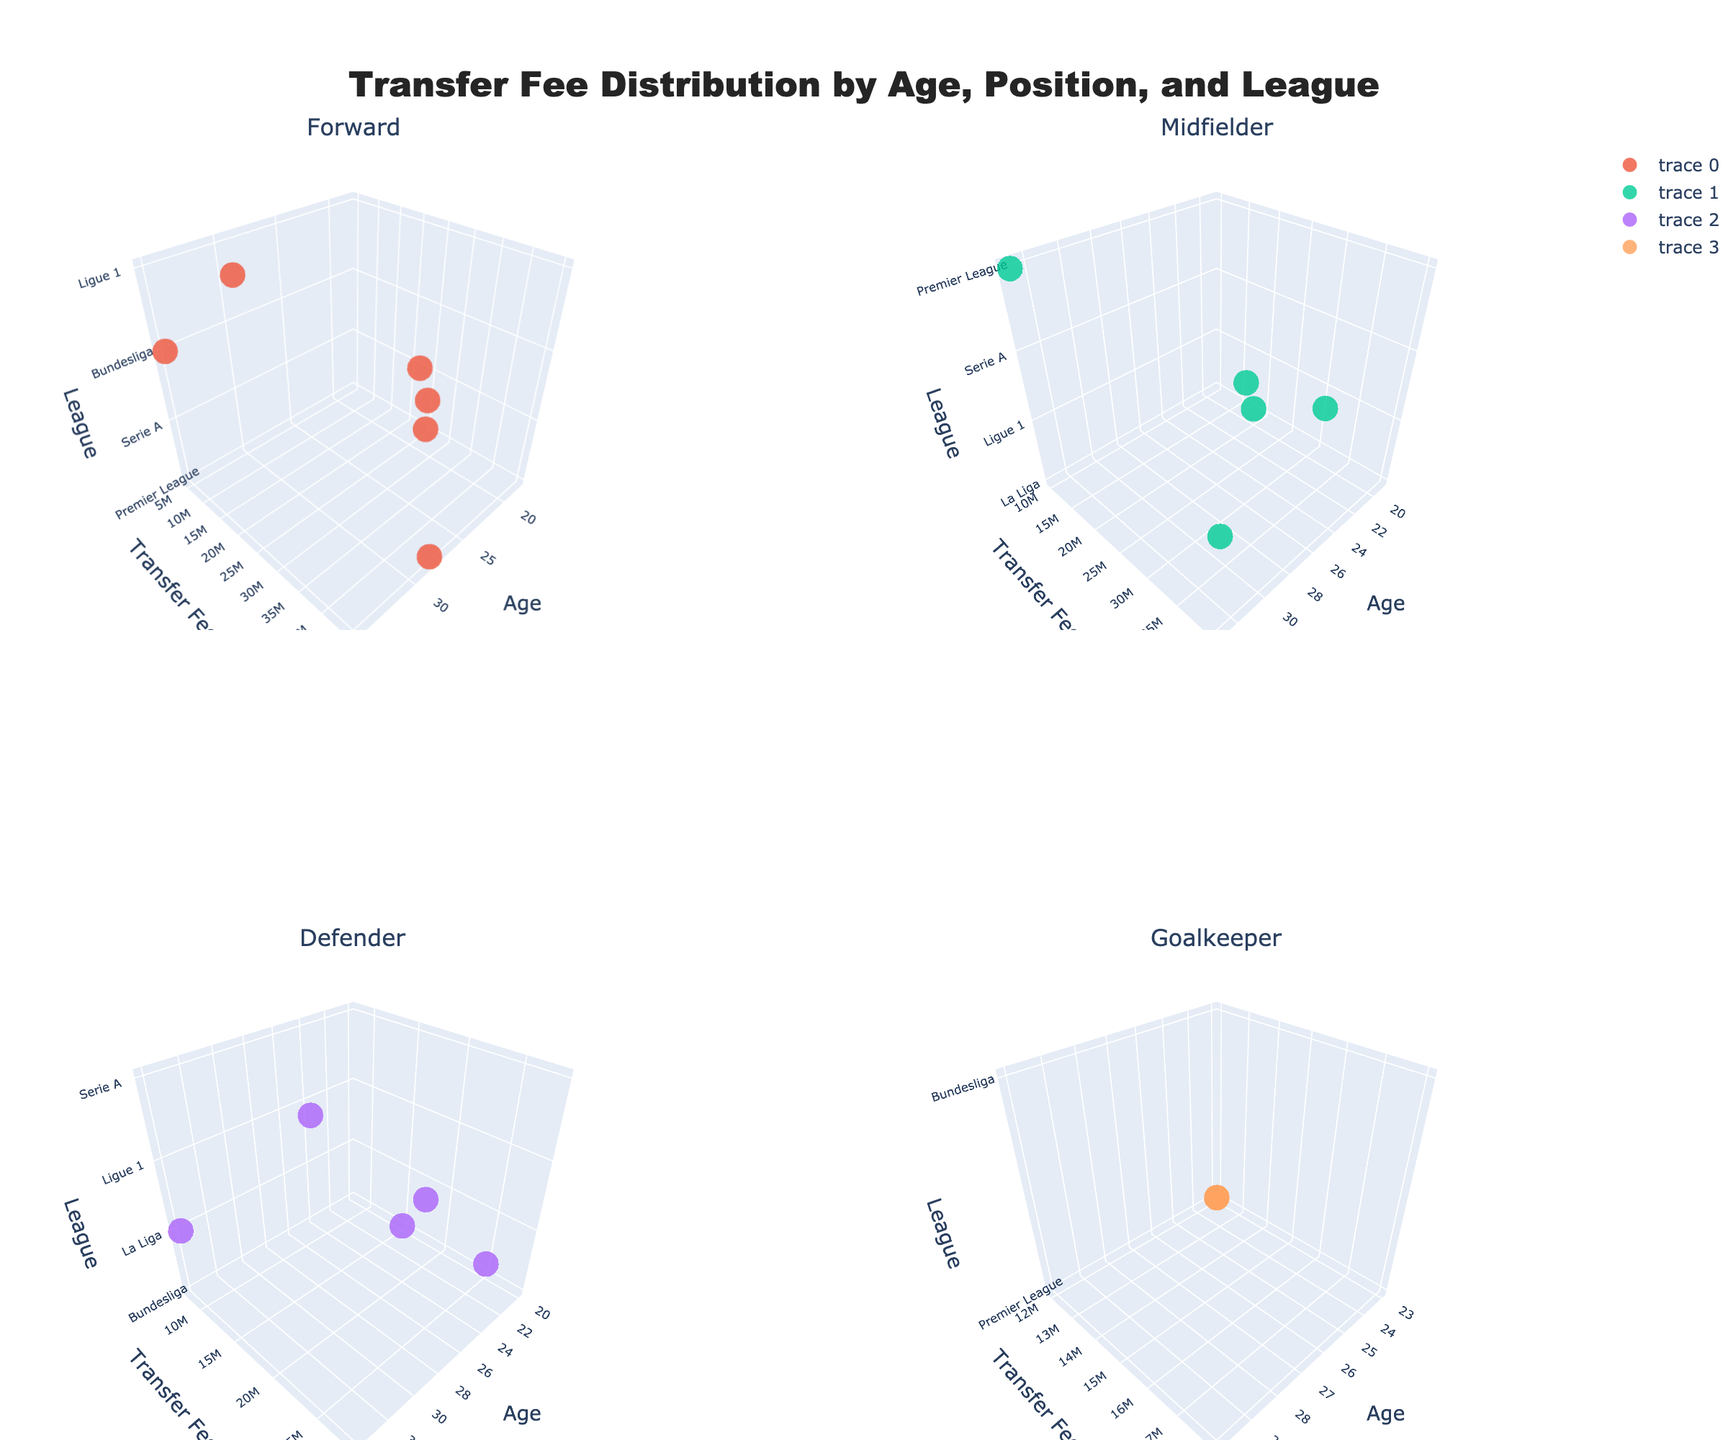what is the title of the figure? The title of the figure is located at the top center of the plot and it describes the overall content of the figure.
Answer: "Transfer Fee Distribution by Age, Position, and League" How many subplots are there in the figure? By looking at the layout of the figure, there are four distinct subplots indicated by separate titles and axis labels.
Answer: 4 Which position has the highest number of data points? By visually comparing the number of markers in each subplot, distinguish which subplot has the most markers. The Forward subplot appears to have the most markers.
Answer: Forward What are the axes labels for each subplot? Each subplot should have three axes labeled: Age on the x-axis, Transfer Fee (€) on the y-axis, and League on the z-axis.
Answer: Age, Transfer Fee (€), League Which age group in the Forward position has the highest transfer fee? In the Forward subplot, find the marker representing the highest position on the y-axis, and check the corresponding age on the x-axis. The highest Transfer Fee for the Forward position is at age 28.
Answer: 28 Are transfer fees generally higher for older Midfielders or younger ones? Observe the distribution of transfer fees along the y-axis for the Midfielders subplot. Compare the positions of markers for older age groups versus younger age groups. Overall, higher transfer fees are associated with Midfielders aged around 26-29.
Answer: Older Midfielders What is the trend in transfer fees for Defenders as they age? Look at the subplot for Defenders and observe how the markers trend along the age axis. Transfer fees seem lower for younger Defenders and peak at middle ages (around 24-27) before decreasing again.
Answer: Increases then decreases Which league has the highest transfer fee for Goalkeepers? In the Goalkeepers subplot, identify the marker that is highest on the y-axis and observe the corresponding League label on the z-axis. The highest transfer fee for Goalkeepers is in the Premier League.
Answer: Premier League Compare the transfer fee of the youngest and oldest player in the Bundesliga. Locate the markers for the Bundesliga in the Forward and Goalkeeper subplots, and compare the y-axis values for the youngest (20, Defender) and oldest (35, Forward) players.
Answer: Youngest: 15M; Oldest: 5M Which subplot square has the most evenly distributed transfer fees across different age groups? Examine each subplot and visually assess the spread of transfer fee markers across a range of ages. The Midfielders subplot seems to show a more even distribution of transfer fees across various ages.
Answer: Midfielders 